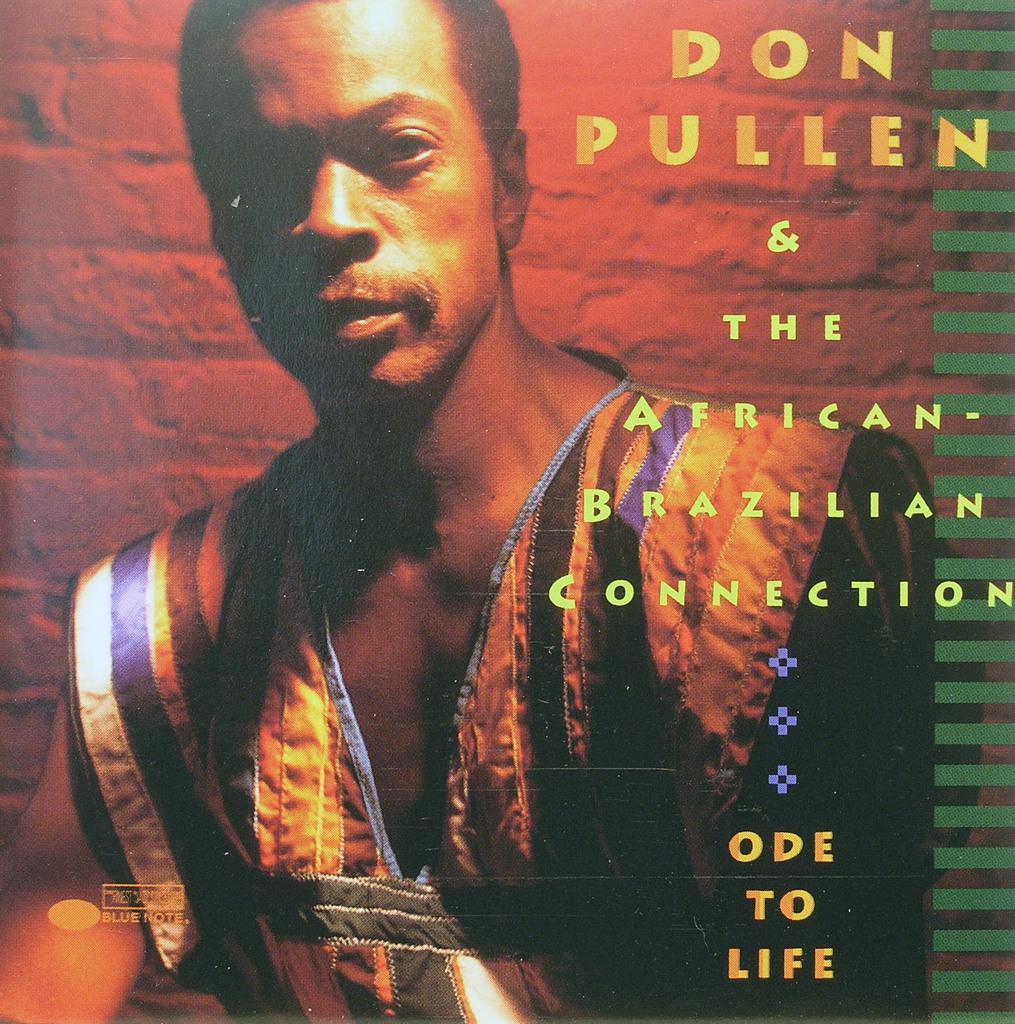Provide a one-sentence caption for the provided image. Don Pullen & the African Brazilian connection cd cover. 